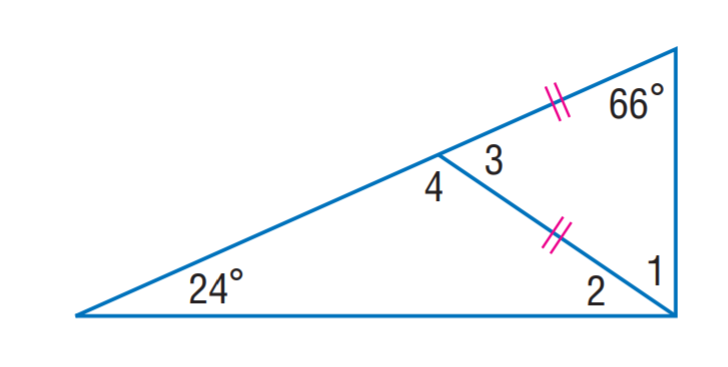Question: Find m \angle 2.
Choices:
A. 12
B. 24
C. 38
D. 66
Answer with the letter. Answer: B Question: Find m \angle 1.
Choices:
A. 24
B. 54
C. 66
D. 78
Answer with the letter. Answer: C 